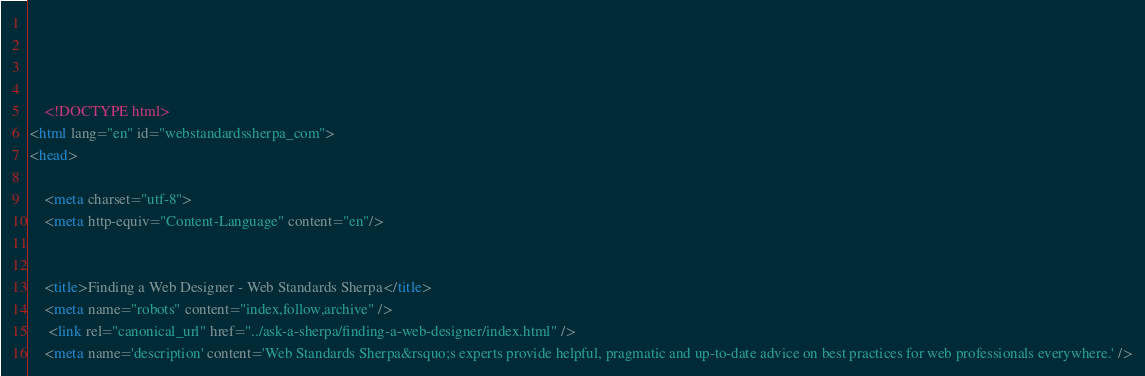<code> <loc_0><loc_0><loc_500><loc_500><_HTML_>	
	
	

	<!DOCTYPE html>
<html lang="en" id="webstandardssherpa_com">
<head>

	<meta charset="utf-8">
	<meta http-equiv="Content-Language" content="en"/>
	

	<title>Finding a Web Designer - Web Standards Sherpa</title>
	<meta name="robots" content="index,follow,archive" />
	 <link rel="canonical_url" href="../ask-a-sherpa/finding-a-web-designer/index.html" /> 
	<meta name='description' content='Web Standards Sherpa&rsquo;s experts provide helpful, pragmatic and up-to-date advice on best practices for web professionals everywhere.' /></code> 